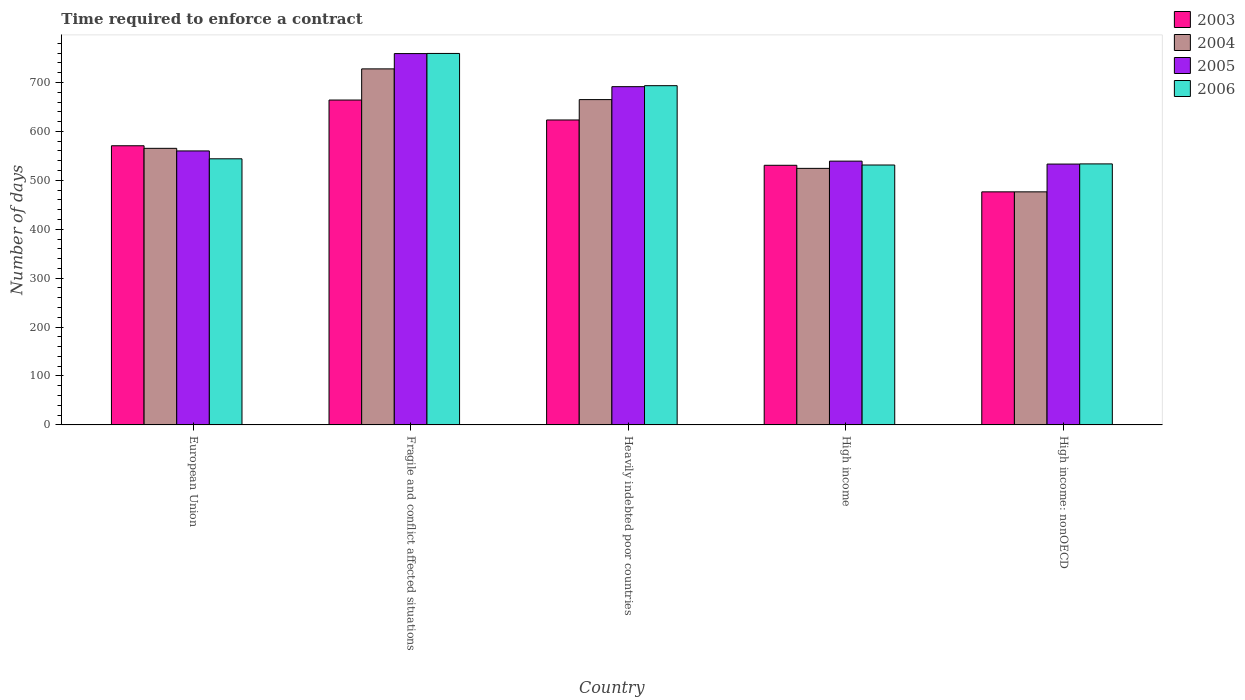How many different coloured bars are there?
Make the answer very short. 4. How many groups of bars are there?
Offer a very short reply. 5. Are the number of bars per tick equal to the number of legend labels?
Offer a very short reply. Yes. How many bars are there on the 4th tick from the right?
Your response must be concise. 4. What is the label of the 3rd group of bars from the left?
Offer a very short reply. Heavily indebted poor countries. What is the number of days required to enforce a contract in 2005 in High income?
Provide a succinct answer. 539.23. Across all countries, what is the maximum number of days required to enforce a contract in 2006?
Your response must be concise. 759.34. Across all countries, what is the minimum number of days required to enforce a contract in 2004?
Give a very brief answer. 476.43. In which country was the number of days required to enforce a contract in 2006 maximum?
Offer a very short reply. Fragile and conflict affected situations. In which country was the number of days required to enforce a contract in 2004 minimum?
Make the answer very short. High income: nonOECD. What is the total number of days required to enforce a contract in 2004 in the graph?
Your answer should be very brief. 2959.03. What is the difference between the number of days required to enforce a contract in 2004 in European Union and that in High income: nonOECD?
Give a very brief answer. 88.93. What is the difference between the number of days required to enforce a contract in 2006 in High income: nonOECD and the number of days required to enforce a contract in 2004 in Fragile and conflict affected situations?
Provide a short and direct response. -194.25. What is the average number of days required to enforce a contract in 2006 per country?
Your response must be concise. 612.32. What is the difference between the number of days required to enforce a contract of/in 2005 and number of days required to enforce a contract of/in 2006 in High income: nonOECD?
Offer a very short reply. -0.34. What is the ratio of the number of days required to enforce a contract in 2003 in European Union to that in Heavily indebted poor countries?
Provide a succinct answer. 0.92. Is the difference between the number of days required to enforce a contract in 2005 in Heavily indebted poor countries and High income greater than the difference between the number of days required to enforce a contract in 2006 in Heavily indebted poor countries and High income?
Provide a succinct answer. No. What is the difference between the highest and the second highest number of days required to enforce a contract in 2004?
Make the answer very short. 99.64. What is the difference between the highest and the lowest number of days required to enforce a contract in 2003?
Your answer should be compact. 187.68. Is it the case that in every country, the sum of the number of days required to enforce a contract in 2006 and number of days required to enforce a contract in 2003 is greater than the sum of number of days required to enforce a contract in 2004 and number of days required to enforce a contract in 2005?
Provide a succinct answer. No. What does the 3rd bar from the right in High income: nonOECD represents?
Provide a succinct answer. 2004. Is it the case that in every country, the sum of the number of days required to enforce a contract in 2005 and number of days required to enforce a contract in 2004 is greater than the number of days required to enforce a contract in 2006?
Keep it short and to the point. Yes. How many bars are there?
Offer a very short reply. 20. Are all the bars in the graph horizontal?
Your answer should be very brief. No. How many countries are there in the graph?
Make the answer very short. 5. What is the difference between two consecutive major ticks on the Y-axis?
Provide a short and direct response. 100. Are the values on the major ticks of Y-axis written in scientific E-notation?
Provide a short and direct response. No. What is the title of the graph?
Provide a short and direct response. Time required to enforce a contract. What is the label or title of the Y-axis?
Provide a short and direct response. Number of days. What is the Number of days in 2003 in European Union?
Your response must be concise. 570.64. What is the Number of days in 2004 in European Union?
Ensure brevity in your answer.  565.36. What is the Number of days of 2005 in European Union?
Your response must be concise. 560.08. What is the Number of days in 2006 in European Union?
Give a very brief answer. 543.96. What is the Number of days in 2003 in Fragile and conflict affected situations?
Offer a very short reply. 664.11. What is the Number of days in 2004 in Fragile and conflict affected situations?
Offer a terse response. 727.8. What is the Number of days of 2005 in Fragile and conflict affected situations?
Give a very brief answer. 759.07. What is the Number of days in 2006 in Fragile and conflict affected situations?
Provide a short and direct response. 759.34. What is the Number of days in 2003 in Heavily indebted poor countries?
Ensure brevity in your answer.  623.34. What is the Number of days in 2004 in Heavily indebted poor countries?
Ensure brevity in your answer.  665. What is the Number of days of 2005 in Heavily indebted poor countries?
Your answer should be very brief. 691.46. What is the Number of days in 2006 in Heavily indebted poor countries?
Offer a very short reply. 693.45. What is the Number of days in 2003 in High income?
Give a very brief answer. 530.71. What is the Number of days in 2004 in High income?
Make the answer very short. 524.44. What is the Number of days of 2005 in High income?
Your answer should be compact. 539.23. What is the Number of days of 2006 in High income?
Your answer should be very brief. 531.28. What is the Number of days of 2003 in High income: nonOECD?
Your answer should be very brief. 476.43. What is the Number of days of 2004 in High income: nonOECD?
Provide a succinct answer. 476.43. What is the Number of days in 2005 in High income: nonOECD?
Your answer should be compact. 533.21. What is the Number of days in 2006 in High income: nonOECD?
Your response must be concise. 533.55. Across all countries, what is the maximum Number of days in 2003?
Your response must be concise. 664.11. Across all countries, what is the maximum Number of days in 2004?
Your answer should be compact. 727.8. Across all countries, what is the maximum Number of days in 2005?
Make the answer very short. 759.07. Across all countries, what is the maximum Number of days in 2006?
Provide a succinct answer. 759.34. Across all countries, what is the minimum Number of days in 2003?
Ensure brevity in your answer.  476.43. Across all countries, what is the minimum Number of days of 2004?
Your response must be concise. 476.43. Across all countries, what is the minimum Number of days in 2005?
Provide a short and direct response. 533.21. Across all countries, what is the minimum Number of days of 2006?
Ensure brevity in your answer.  531.28. What is the total Number of days in 2003 in the graph?
Your response must be concise. 2865.23. What is the total Number of days in 2004 in the graph?
Give a very brief answer. 2959.03. What is the total Number of days in 2005 in the graph?
Give a very brief answer. 3083.05. What is the total Number of days in 2006 in the graph?
Make the answer very short. 3061.58. What is the difference between the Number of days of 2003 in European Union and that in Fragile and conflict affected situations?
Provide a succinct answer. -93.47. What is the difference between the Number of days in 2004 in European Union and that in Fragile and conflict affected situations?
Offer a terse response. -162.44. What is the difference between the Number of days in 2005 in European Union and that in Fragile and conflict affected situations?
Your answer should be compact. -198.99. What is the difference between the Number of days in 2006 in European Union and that in Fragile and conflict affected situations?
Give a very brief answer. -215.38. What is the difference between the Number of days in 2003 in European Union and that in Heavily indebted poor countries?
Your answer should be compact. -52.7. What is the difference between the Number of days of 2004 in European Union and that in Heavily indebted poor countries?
Make the answer very short. -99.64. What is the difference between the Number of days of 2005 in European Union and that in Heavily indebted poor countries?
Give a very brief answer. -131.38. What is the difference between the Number of days of 2006 in European Union and that in Heavily indebted poor countries?
Your answer should be very brief. -149.49. What is the difference between the Number of days in 2003 in European Union and that in High income?
Provide a short and direct response. 39.93. What is the difference between the Number of days of 2004 in European Union and that in High income?
Offer a terse response. 40.92. What is the difference between the Number of days of 2005 in European Union and that in High income?
Offer a terse response. 20.85. What is the difference between the Number of days in 2006 in European Union and that in High income?
Your answer should be very brief. 12.68. What is the difference between the Number of days of 2003 in European Union and that in High income: nonOECD?
Your response must be concise. 94.21. What is the difference between the Number of days of 2004 in European Union and that in High income: nonOECD?
Your response must be concise. 88.93. What is the difference between the Number of days in 2005 in European Union and that in High income: nonOECD?
Offer a terse response. 26.87. What is the difference between the Number of days in 2006 in European Union and that in High income: nonOECD?
Your response must be concise. 10.41. What is the difference between the Number of days of 2003 in Fragile and conflict affected situations and that in Heavily indebted poor countries?
Offer a terse response. 40.76. What is the difference between the Number of days of 2004 in Fragile and conflict affected situations and that in Heavily indebted poor countries?
Provide a succinct answer. 62.8. What is the difference between the Number of days in 2005 in Fragile and conflict affected situations and that in Heavily indebted poor countries?
Keep it short and to the point. 67.61. What is the difference between the Number of days in 2006 in Fragile and conflict affected situations and that in Heavily indebted poor countries?
Offer a terse response. 65.9. What is the difference between the Number of days in 2003 in Fragile and conflict affected situations and that in High income?
Offer a terse response. 133.39. What is the difference between the Number of days in 2004 in Fragile and conflict affected situations and that in High income?
Provide a short and direct response. 203.36. What is the difference between the Number of days in 2005 in Fragile and conflict affected situations and that in High income?
Provide a short and direct response. 219.84. What is the difference between the Number of days in 2006 in Fragile and conflict affected situations and that in High income?
Give a very brief answer. 228.06. What is the difference between the Number of days in 2003 in Fragile and conflict affected situations and that in High income: nonOECD?
Ensure brevity in your answer.  187.68. What is the difference between the Number of days in 2004 in Fragile and conflict affected situations and that in High income: nonOECD?
Make the answer very short. 251.37. What is the difference between the Number of days in 2005 in Fragile and conflict affected situations and that in High income: nonOECD?
Provide a succinct answer. 225.86. What is the difference between the Number of days in 2006 in Fragile and conflict affected situations and that in High income: nonOECD?
Make the answer very short. 225.79. What is the difference between the Number of days of 2003 in Heavily indebted poor countries and that in High income?
Provide a short and direct response. 92.63. What is the difference between the Number of days in 2004 in Heavily indebted poor countries and that in High income?
Provide a short and direct response. 140.56. What is the difference between the Number of days of 2005 in Heavily indebted poor countries and that in High income?
Your response must be concise. 152.23. What is the difference between the Number of days in 2006 in Heavily indebted poor countries and that in High income?
Keep it short and to the point. 162.17. What is the difference between the Number of days in 2003 in Heavily indebted poor countries and that in High income: nonOECD?
Give a very brief answer. 146.92. What is the difference between the Number of days in 2004 in Heavily indebted poor countries and that in High income: nonOECD?
Offer a terse response. 188.57. What is the difference between the Number of days in 2005 in Heavily indebted poor countries and that in High income: nonOECD?
Make the answer very short. 158.25. What is the difference between the Number of days in 2006 in Heavily indebted poor countries and that in High income: nonOECD?
Your response must be concise. 159.9. What is the difference between the Number of days in 2003 in High income and that in High income: nonOECD?
Offer a very short reply. 54.29. What is the difference between the Number of days in 2004 in High income and that in High income: nonOECD?
Offer a very short reply. 48.01. What is the difference between the Number of days of 2005 in High income and that in High income: nonOECD?
Your response must be concise. 6.02. What is the difference between the Number of days in 2006 in High income and that in High income: nonOECD?
Your answer should be very brief. -2.27. What is the difference between the Number of days in 2003 in European Union and the Number of days in 2004 in Fragile and conflict affected situations?
Your answer should be very brief. -157.16. What is the difference between the Number of days in 2003 in European Union and the Number of days in 2005 in Fragile and conflict affected situations?
Offer a very short reply. -188.43. What is the difference between the Number of days of 2003 in European Union and the Number of days of 2006 in Fragile and conflict affected situations?
Make the answer very short. -188.7. What is the difference between the Number of days in 2004 in European Union and the Number of days in 2005 in Fragile and conflict affected situations?
Your answer should be compact. -193.71. What is the difference between the Number of days of 2004 in European Union and the Number of days of 2006 in Fragile and conflict affected situations?
Offer a very short reply. -193.98. What is the difference between the Number of days of 2005 in European Union and the Number of days of 2006 in Fragile and conflict affected situations?
Your response must be concise. -199.26. What is the difference between the Number of days of 2003 in European Union and the Number of days of 2004 in Heavily indebted poor countries?
Provide a short and direct response. -94.36. What is the difference between the Number of days of 2003 in European Union and the Number of days of 2005 in Heavily indebted poor countries?
Your answer should be very brief. -120.82. What is the difference between the Number of days in 2003 in European Union and the Number of days in 2006 in Heavily indebted poor countries?
Offer a very short reply. -122.81. What is the difference between the Number of days in 2004 in European Union and the Number of days in 2005 in Heavily indebted poor countries?
Your answer should be very brief. -126.1. What is the difference between the Number of days of 2004 in European Union and the Number of days of 2006 in Heavily indebted poor countries?
Offer a very short reply. -128.09. What is the difference between the Number of days in 2005 in European Union and the Number of days in 2006 in Heavily indebted poor countries?
Provide a short and direct response. -133.37. What is the difference between the Number of days in 2003 in European Union and the Number of days in 2004 in High income?
Offer a terse response. 46.2. What is the difference between the Number of days in 2003 in European Union and the Number of days in 2005 in High income?
Offer a very short reply. 31.41. What is the difference between the Number of days in 2003 in European Union and the Number of days in 2006 in High income?
Keep it short and to the point. 39.36. What is the difference between the Number of days in 2004 in European Union and the Number of days in 2005 in High income?
Your answer should be compact. 26.13. What is the difference between the Number of days in 2004 in European Union and the Number of days in 2006 in High income?
Ensure brevity in your answer.  34.08. What is the difference between the Number of days in 2005 in European Union and the Number of days in 2006 in High income?
Your response must be concise. 28.8. What is the difference between the Number of days in 2003 in European Union and the Number of days in 2004 in High income: nonOECD?
Keep it short and to the point. 94.21. What is the difference between the Number of days of 2003 in European Union and the Number of days of 2005 in High income: nonOECD?
Keep it short and to the point. 37.43. What is the difference between the Number of days in 2003 in European Union and the Number of days in 2006 in High income: nonOECD?
Your response must be concise. 37.09. What is the difference between the Number of days of 2004 in European Union and the Number of days of 2005 in High income: nonOECD?
Your answer should be very brief. 32.15. What is the difference between the Number of days in 2004 in European Union and the Number of days in 2006 in High income: nonOECD?
Your answer should be very brief. 31.81. What is the difference between the Number of days in 2005 in European Union and the Number of days in 2006 in High income: nonOECD?
Keep it short and to the point. 26.53. What is the difference between the Number of days in 2003 in Fragile and conflict affected situations and the Number of days in 2004 in Heavily indebted poor countries?
Ensure brevity in your answer.  -0.89. What is the difference between the Number of days in 2003 in Fragile and conflict affected situations and the Number of days in 2005 in Heavily indebted poor countries?
Keep it short and to the point. -27.35. What is the difference between the Number of days of 2003 in Fragile and conflict affected situations and the Number of days of 2006 in Heavily indebted poor countries?
Provide a succinct answer. -29.34. What is the difference between the Number of days of 2004 in Fragile and conflict affected situations and the Number of days of 2005 in Heavily indebted poor countries?
Offer a terse response. 36.34. What is the difference between the Number of days in 2004 in Fragile and conflict affected situations and the Number of days in 2006 in Heavily indebted poor countries?
Make the answer very short. 34.35. What is the difference between the Number of days in 2005 in Fragile and conflict affected situations and the Number of days in 2006 in Heavily indebted poor countries?
Make the answer very short. 65.62. What is the difference between the Number of days of 2003 in Fragile and conflict affected situations and the Number of days of 2004 in High income?
Provide a short and direct response. 139.66. What is the difference between the Number of days of 2003 in Fragile and conflict affected situations and the Number of days of 2005 in High income?
Ensure brevity in your answer.  124.88. What is the difference between the Number of days of 2003 in Fragile and conflict affected situations and the Number of days of 2006 in High income?
Make the answer very short. 132.83. What is the difference between the Number of days of 2004 in Fragile and conflict affected situations and the Number of days of 2005 in High income?
Provide a short and direct response. 188.57. What is the difference between the Number of days of 2004 in Fragile and conflict affected situations and the Number of days of 2006 in High income?
Provide a short and direct response. 196.52. What is the difference between the Number of days in 2005 in Fragile and conflict affected situations and the Number of days in 2006 in High income?
Ensure brevity in your answer.  227.79. What is the difference between the Number of days in 2003 in Fragile and conflict affected situations and the Number of days in 2004 in High income: nonOECD?
Offer a terse response. 187.68. What is the difference between the Number of days of 2003 in Fragile and conflict affected situations and the Number of days of 2005 in High income: nonOECD?
Offer a terse response. 130.89. What is the difference between the Number of days in 2003 in Fragile and conflict affected situations and the Number of days in 2006 in High income: nonOECD?
Keep it short and to the point. 130.56. What is the difference between the Number of days in 2004 in Fragile and conflict affected situations and the Number of days in 2005 in High income: nonOECD?
Your answer should be very brief. 194.59. What is the difference between the Number of days of 2004 in Fragile and conflict affected situations and the Number of days of 2006 in High income: nonOECD?
Provide a succinct answer. 194.25. What is the difference between the Number of days of 2005 in Fragile and conflict affected situations and the Number of days of 2006 in High income: nonOECD?
Provide a short and direct response. 225.52. What is the difference between the Number of days of 2003 in Heavily indebted poor countries and the Number of days of 2004 in High income?
Offer a terse response. 98.9. What is the difference between the Number of days of 2003 in Heavily indebted poor countries and the Number of days of 2005 in High income?
Offer a terse response. 84.12. What is the difference between the Number of days of 2003 in Heavily indebted poor countries and the Number of days of 2006 in High income?
Provide a short and direct response. 92.06. What is the difference between the Number of days of 2004 in Heavily indebted poor countries and the Number of days of 2005 in High income?
Provide a succinct answer. 125.77. What is the difference between the Number of days of 2004 in Heavily indebted poor countries and the Number of days of 2006 in High income?
Offer a very short reply. 133.72. What is the difference between the Number of days in 2005 in Heavily indebted poor countries and the Number of days in 2006 in High income?
Give a very brief answer. 160.18. What is the difference between the Number of days of 2003 in Heavily indebted poor countries and the Number of days of 2004 in High income: nonOECD?
Ensure brevity in your answer.  146.92. What is the difference between the Number of days of 2003 in Heavily indebted poor countries and the Number of days of 2005 in High income: nonOECD?
Ensure brevity in your answer.  90.13. What is the difference between the Number of days of 2003 in Heavily indebted poor countries and the Number of days of 2006 in High income: nonOECD?
Provide a short and direct response. 89.79. What is the difference between the Number of days of 2004 in Heavily indebted poor countries and the Number of days of 2005 in High income: nonOECD?
Ensure brevity in your answer.  131.79. What is the difference between the Number of days in 2004 in Heavily indebted poor countries and the Number of days in 2006 in High income: nonOECD?
Ensure brevity in your answer.  131.45. What is the difference between the Number of days of 2005 in Heavily indebted poor countries and the Number of days of 2006 in High income: nonOECD?
Make the answer very short. 157.91. What is the difference between the Number of days in 2003 in High income and the Number of days in 2004 in High income: nonOECD?
Make the answer very short. 54.29. What is the difference between the Number of days of 2003 in High income and the Number of days of 2005 in High income: nonOECD?
Your response must be concise. -2.5. What is the difference between the Number of days in 2003 in High income and the Number of days in 2006 in High income: nonOECD?
Your response must be concise. -2.84. What is the difference between the Number of days in 2004 in High income and the Number of days in 2005 in High income: nonOECD?
Your response must be concise. -8.77. What is the difference between the Number of days in 2004 in High income and the Number of days in 2006 in High income: nonOECD?
Provide a short and direct response. -9.11. What is the difference between the Number of days of 2005 in High income and the Number of days of 2006 in High income: nonOECD?
Offer a terse response. 5.68. What is the average Number of days of 2003 per country?
Your response must be concise. 573.05. What is the average Number of days in 2004 per country?
Offer a very short reply. 591.81. What is the average Number of days in 2005 per country?
Offer a very short reply. 616.61. What is the average Number of days in 2006 per country?
Offer a very short reply. 612.32. What is the difference between the Number of days in 2003 and Number of days in 2004 in European Union?
Give a very brief answer. 5.28. What is the difference between the Number of days of 2003 and Number of days of 2005 in European Union?
Offer a terse response. 10.56. What is the difference between the Number of days of 2003 and Number of days of 2006 in European Union?
Offer a terse response. 26.68. What is the difference between the Number of days of 2004 and Number of days of 2005 in European Union?
Your answer should be compact. 5.28. What is the difference between the Number of days in 2004 and Number of days in 2006 in European Union?
Give a very brief answer. 21.4. What is the difference between the Number of days in 2005 and Number of days in 2006 in European Union?
Provide a short and direct response. 16.12. What is the difference between the Number of days in 2003 and Number of days in 2004 in Fragile and conflict affected situations?
Offer a very short reply. -63.69. What is the difference between the Number of days in 2003 and Number of days in 2005 in Fragile and conflict affected situations?
Your answer should be very brief. -94.97. What is the difference between the Number of days in 2003 and Number of days in 2006 in Fragile and conflict affected situations?
Keep it short and to the point. -95.24. What is the difference between the Number of days of 2004 and Number of days of 2005 in Fragile and conflict affected situations?
Make the answer very short. -31.27. What is the difference between the Number of days of 2004 and Number of days of 2006 in Fragile and conflict affected situations?
Offer a very short reply. -31.54. What is the difference between the Number of days of 2005 and Number of days of 2006 in Fragile and conflict affected situations?
Your answer should be compact. -0.27. What is the difference between the Number of days in 2003 and Number of days in 2004 in Heavily indebted poor countries?
Provide a succinct answer. -41.66. What is the difference between the Number of days in 2003 and Number of days in 2005 in Heavily indebted poor countries?
Make the answer very short. -68.11. What is the difference between the Number of days in 2003 and Number of days in 2006 in Heavily indebted poor countries?
Your answer should be very brief. -70.1. What is the difference between the Number of days in 2004 and Number of days in 2005 in Heavily indebted poor countries?
Offer a very short reply. -26.46. What is the difference between the Number of days of 2004 and Number of days of 2006 in Heavily indebted poor countries?
Provide a succinct answer. -28.45. What is the difference between the Number of days of 2005 and Number of days of 2006 in Heavily indebted poor countries?
Offer a terse response. -1.99. What is the difference between the Number of days of 2003 and Number of days of 2004 in High income?
Your answer should be very brief. 6.27. What is the difference between the Number of days in 2003 and Number of days in 2005 in High income?
Ensure brevity in your answer.  -8.51. What is the difference between the Number of days in 2003 and Number of days in 2006 in High income?
Provide a succinct answer. -0.57. What is the difference between the Number of days in 2004 and Number of days in 2005 in High income?
Give a very brief answer. -14.79. What is the difference between the Number of days in 2004 and Number of days in 2006 in High income?
Keep it short and to the point. -6.84. What is the difference between the Number of days of 2005 and Number of days of 2006 in High income?
Provide a short and direct response. 7.95. What is the difference between the Number of days of 2003 and Number of days of 2005 in High income: nonOECD?
Provide a short and direct response. -56.78. What is the difference between the Number of days in 2003 and Number of days in 2006 in High income: nonOECD?
Your answer should be compact. -57.12. What is the difference between the Number of days in 2004 and Number of days in 2005 in High income: nonOECD?
Ensure brevity in your answer.  -56.78. What is the difference between the Number of days of 2004 and Number of days of 2006 in High income: nonOECD?
Give a very brief answer. -57.12. What is the difference between the Number of days in 2005 and Number of days in 2006 in High income: nonOECD?
Provide a succinct answer. -0.34. What is the ratio of the Number of days of 2003 in European Union to that in Fragile and conflict affected situations?
Ensure brevity in your answer.  0.86. What is the ratio of the Number of days in 2004 in European Union to that in Fragile and conflict affected situations?
Your answer should be very brief. 0.78. What is the ratio of the Number of days in 2005 in European Union to that in Fragile and conflict affected situations?
Ensure brevity in your answer.  0.74. What is the ratio of the Number of days in 2006 in European Union to that in Fragile and conflict affected situations?
Provide a short and direct response. 0.72. What is the ratio of the Number of days of 2003 in European Union to that in Heavily indebted poor countries?
Your response must be concise. 0.92. What is the ratio of the Number of days in 2004 in European Union to that in Heavily indebted poor countries?
Your answer should be very brief. 0.85. What is the ratio of the Number of days in 2005 in European Union to that in Heavily indebted poor countries?
Ensure brevity in your answer.  0.81. What is the ratio of the Number of days in 2006 in European Union to that in Heavily indebted poor countries?
Ensure brevity in your answer.  0.78. What is the ratio of the Number of days of 2003 in European Union to that in High income?
Offer a very short reply. 1.08. What is the ratio of the Number of days of 2004 in European Union to that in High income?
Provide a short and direct response. 1.08. What is the ratio of the Number of days of 2005 in European Union to that in High income?
Offer a very short reply. 1.04. What is the ratio of the Number of days of 2006 in European Union to that in High income?
Your response must be concise. 1.02. What is the ratio of the Number of days in 2003 in European Union to that in High income: nonOECD?
Provide a succinct answer. 1.2. What is the ratio of the Number of days in 2004 in European Union to that in High income: nonOECD?
Keep it short and to the point. 1.19. What is the ratio of the Number of days in 2005 in European Union to that in High income: nonOECD?
Make the answer very short. 1.05. What is the ratio of the Number of days in 2006 in European Union to that in High income: nonOECD?
Make the answer very short. 1.02. What is the ratio of the Number of days in 2003 in Fragile and conflict affected situations to that in Heavily indebted poor countries?
Provide a succinct answer. 1.07. What is the ratio of the Number of days of 2004 in Fragile and conflict affected situations to that in Heavily indebted poor countries?
Offer a very short reply. 1.09. What is the ratio of the Number of days of 2005 in Fragile and conflict affected situations to that in Heavily indebted poor countries?
Provide a succinct answer. 1.1. What is the ratio of the Number of days in 2006 in Fragile and conflict affected situations to that in Heavily indebted poor countries?
Give a very brief answer. 1.09. What is the ratio of the Number of days in 2003 in Fragile and conflict affected situations to that in High income?
Offer a terse response. 1.25. What is the ratio of the Number of days of 2004 in Fragile and conflict affected situations to that in High income?
Your answer should be very brief. 1.39. What is the ratio of the Number of days in 2005 in Fragile and conflict affected situations to that in High income?
Ensure brevity in your answer.  1.41. What is the ratio of the Number of days in 2006 in Fragile and conflict affected situations to that in High income?
Offer a very short reply. 1.43. What is the ratio of the Number of days of 2003 in Fragile and conflict affected situations to that in High income: nonOECD?
Your answer should be compact. 1.39. What is the ratio of the Number of days of 2004 in Fragile and conflict affected situations to that in High income: nonOECD?
Provide a short and direct response. 1.53. What is the ratio of the Number of days in 2005 in Fragile and conflict affected situations to that in High income: nonOECD?
Make the answer very short. 1.42. What is the ratio of the Number of days of 2006 in Fragile and conflict affected situations to that in High income: nonOECD?
Keep it short and to the point. 1.42. What is the ratio of the Number of days in 2003 in Heavily indebted poor countries to that in High income?
Make the answer very short. 1.17. What is the ratio of the Number of days of 2004 in Heavily indebted poor countries to that in High income?
Your answer should be very brief. 1.27. What is the ratio of the Number of days of 2005 in Heavily indebted poor countries to that in High income?
Your answer should be very brief. 1.28. What is the ratio of the Number of days of 2006 in Heavily indebted poor countries to that in High income?
Make the answer very short. 1.31. What is the ratio of the Number of days of 2003 in Heavily indebted poor countries to that in High income: nonOECD?
Provide a short and direct response. 1.31. What is the ratio of the Number of days in 2004 in Heavily indebted poor countries to that in High income: nonOECD?
Give a very brief answer. 1.4. What is the ratio of the Number of days in 2005 in Heavily indebted poor countries to that in High income: nonOECD?
Your answer should be compact. 1.3. What is the ratio of the Number of days of 2006 in Heavily indebted poor countries to that in High income: nonOECD?
Provide a succinct answer. 1.3. What is the ratio of the Number of days of 2003 in High income to that in High income: nonOECD?
Offer a very short reply. 1.11. What is the ratio of the Number of days in 2004 in High income to that in High income: nonOECD?
Make the answer very short. 1.1. What is the ratio of the Number of days of 2005 in High income to that in High income: nonOECD?
Offer a terse response. 1.01. What is the ratio of the Number of days of 2006 in High income to that in High income: nonOECD?
Offer a terse response. 1. What is the difference between the highest and the second highest Number of days of 2003?
Offer a very short reply. 40.76. What is the difference between the highest and the second highest Number of days in 2004?
Ensure brevity in your answer.  62.8. What is the difference between the highest and the second highest Number of days in 2005?
Provide a short and direct response. 67.61. What is the difference between the highest and the second highest Number of days in 2006?
Your response must be concise. 65.9. What is the difference between the highest and the lowest Number of days of 2003?
Provide a succinct answer. 187.68. What is the difference between the highest and the lowest Number of days in 2004?
Offer a very short reply. 251.37. What is the difference between the highest and the lowest Number of days of 2005?
Provide a succinct answer. 225.86. What is the difference between the highest and the lowest Number of days of 2006?
Your answer should be very brief. 228.06. 